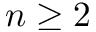Convert formula to latex. <formula><loc_0><loc_0><loc_500><loc_500>n \geq 2</formula> 